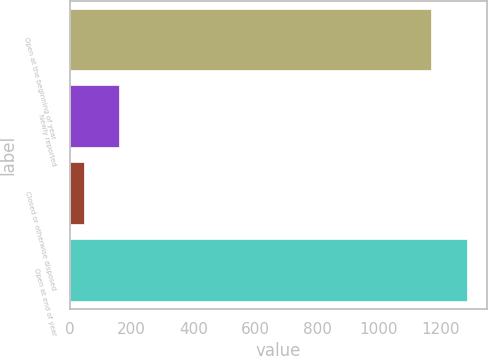Convert chart to OTSL. <chart><loc_0><loc_0><loc_500><loc_500><bar_chart><fcel>Open at the beginning of year<fcel>Newly reported<fcel>Closed or otherwise disposed<fcel>Open at end of year<nl><fcel>1169<fcel>161.2<fcel>46<fcel>1284.2<nl></chart> 